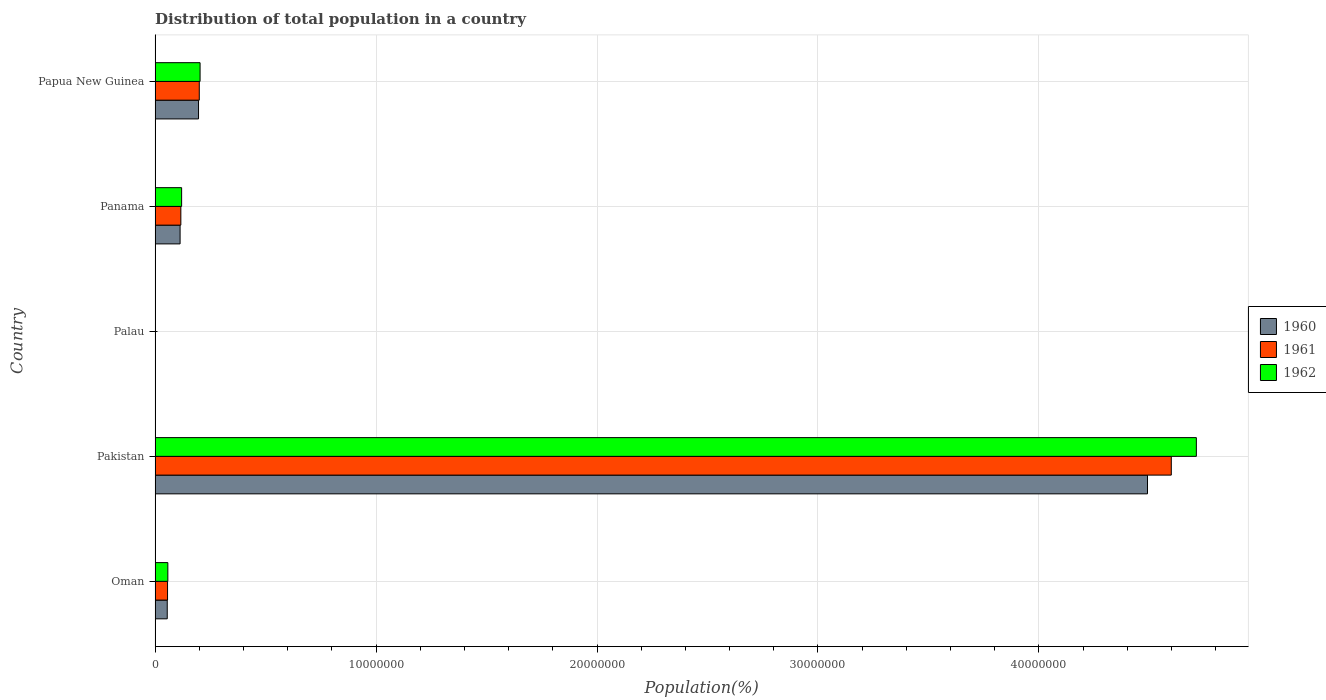How many different coloured bars are there?
Offer a terse response. 3. How many groups of bars are there?
Offer a terse response. 5. Are the number of bars per tick equal to the number of legend labels?
Your answer should be very brief. Yes. Are the number of bars on each tick of the Y-axis equal?
Provide a short and direct response. Yes. How many bars are there on the 4th tick from the top?
Make the answer very short. 3. What is the label of the 1st group of bars from the top?
Offer a terse response. Papua New Guinea. What is the population of in 1961 in Palau?
Make the answer very short. 9901. Across all countries, what is the maximum population of in 1962?
Your answer should be very brief. 4.71e+07. Across all countries, what is the minimum population of in 1962?
Provide a short and direct response. 1.02e+04. In which country was the population of in 1960 maximum?
Offer a very short reply. Pakistan. In which country was the population of in 1960 minimum?
Your response must be concise. Palau. What is the total population of in 1960 in the graph?
Provide a succinct answer. 4.86e+07. What is the difference between the population of in 1961 in Palau and that in Papua New Guinea?
Make the answer very short. -1.99e+06. What is the difference between the population of in 1960 in Papua New Guinea and the population of in 1962 in Palau?
Your answer should be very brief. 1.96e+06. What is the average population of in 1960 per country?
Make the answer very short. 9.71e+06. What is the difference between the population of in 1961 and population of in 1960 in Pakistan?
Your response must be concise. 1.08e+06. What is the ratio of the population of in 1962 in Pakistan to that in Palau?
Provide a succinct answer. 4642.65. What is the difference between the highest and the second highest population of in 1960?
Ensure brevity in your answer.  4.29e+07. What is the difference between the highest and the lowest population of in 1961?
Keep it short and to the point. 4.60e+07. Is the sum of the population of in 1960 in Pakistan and Panama greater than the maximum population of in 1962 across all countries?
Give a very brief answer. No. What does the 2nd bar from the bottom in Pakistan represents?
Make the answer very short. 1961. How many bars are there?
Keep it short and to the point. 15. How many countries are there in the graph?
Keep it short and to the point. 5. What is the difference between two consecutive major ticks on the X-axis?
Your answer should be compact. 1.00e+07. How many legend labels are there?
Give a very brief answer. 3. How are the legend labels stacked?
Keep it short and to the point. Vertical. What is the title of the graph?
Keep it short and to the point. Distribution of total population in a country. What is the label or title of the X-axis?
Provide a short and direct response. Population(%). What is the label or title of the Y-axis?
Your answer should be compact. Country. What is the Population(%) in 1960 in Oman?
Your response must be concise. 5.52e+05. What is the Population(%) in 1961 in Oman?
Ensure brevity in your answer.  5.65e+05. What is the Population(%) in 1962 in Oman?
Offer a very short reply. 5.79e+05. What is the Population(%) in 1960 in Pakistan?
Keep it short and to the point. 4.49e+07. What is the Population(%) of 1961 in Pakistan?
Make the answer very short. 4.60e+07. What is the Population(%) of 1962 in Pakistan?
Offer a terse response. 4.71e+07. What is the Population(%) in 1960 in Palau?
Ensure brevity in your answer.  9638. What is the Population(%) of 1961 in Palau?
Keep it short and to the point. 9901. What is the Population(%) of 1962 in Palau?
Make the answer very short. 1.02e+04. What is the Population(%) of 1960 in Panama?
Offer a terse response. 1.13e+06. What is the Population(%) in 1961 in Panama?
Ensure brevity in your answer.  1.17e+06. What is the Population(%) of 1962 in Panama?
Offer a very short reply. 1.20e+06. What is the Population(%) in 1960 in Papua New Guinea?
Provide a short and direct response. 1.97e+06. What is the Population(%) of 1961 in Papua New Guinea?
Make the answer very short. 2.00e+06. What is the Population(%) of 1962 in Papua New Guinea?
Your response must be concise. 2.04e+06. Across all countries, what is the maximum Population(%) in 1960?
Your response must be concise. 4.49e+07. Across all countries, what is the maximum Population(%) of 1961?
Offer a terse response. 4.60e+07. Across all countries, what is the maximum Population(%) of 1962?
Offer a terse response. 4.71e+07. Across all countries, what is the minimum Population(%) of 1960?
Offer a very short reply. 9638. Across all countries, what is the minimum Population(%) of 1961?
Keep it short and to the point. 9901. Across all countries, what is the minimum Population(%) in 1962?
Provide a succinct answer. 1.02e+04. What is the total Population(%) of 1960 in the graph?
Offer a terse response. 4.86e+07. What is the total Population(%) of 1961 in the graph?
Offer a very short reply. 4.97e+07. What is the total Population(%) in 1962 in the graph?
Your response must be concise. 5.10e+07. What is the difference between the Population(%) of 1960 in Oman and that in Pakistan?
Your answer should be compact. -4.44e+07. What is the difference between the Population(%) of 1961 in Oman and that in Pakistan?
Provide a succinct answer. -4.54e+07. What is the difference between the Population(%) in 1962 in Oman and that in Pakistan?
Offer a terse response. -4.65e+07. What is the difference between the Population(%) in 1960 in Oman and that in Palau?
Ensure brevity in your answer.  5.42e+05. What is the difference between the Population(%) of 1961 in Oman and that in Palau?
Provide a short and direct response. 5.55e+05. What is the difference between the Population(%) of 1962 in Oman and that in Palau?
Your answer should be compact. 5.69e+05. What is the difference between the Population(%) in 1960 in Oman and that in Panama?
Your response must be concise. -5.81e+05. What is the difference between the Population(%) of 1961 in Oman and that in Panama?
Ensure brevity in your answer.  -6.02e+05. What is the difference between the Population(%) of 1962 in Oman and that in Panama?
Provide a short and direct response. -6.24e+05. What is the difference between the Population(%) in 1960 in Oman and that in Papua New Guinea?
Provide a succinct answer. -1.42e+06. What is the difference between the Population(%) of 1961 in Oman and that in Papua New Guinea?
Keep it short and to the point. -1.44e+06. What is the difference between the Population(%) of 1962 in Oman and that in Papua New Guinea?
Your response must be concise. -1.46e+06. What is the difference between the Population(%) in 1960 in Pakistan and that in Palau?
Provide a short and direct response. 4.49e+07. What is the difference between the Population(%) of 1961 in Pakistan and that in Palau?
Provide a succinct answer. 4.60e+07. What is the difference between the Population(%) in 1962 in Pakistan and that in Palau?
Offer a terse response. 4.71e+07. What is the difference between the Population(%) of 1960 in Pakistan and that in Panama?
Offer a terse response. 4.38e+07. What is the difference between the Population(%) of 1961 in Pakistan and that in Panama?
Give a very brief answer. 4.48e+07. What is the difference between the Population(%) in 1962 in Pakistan and that in Panama?
Your answer should be compact. 4.59e+07. What is the difference between the Population(%) of 1960 in Pakistan and that in Papua New Guinea?
Your answer should be very brief. 4.29e+07. What is the difference between the Population(%) of 1961 in Pakistan and that in Papua New Guinea?
Offer a very short reply. 4.40e+07. What is the difference between the Population(%) of 1962 in Pakistan and that in Papua New Guinea?
Make the answer very short. 4.51e+07. What is the difference between the Population(%) in 1960 in Palau and that in Panama?
Your response must be concise. -1.12e+06. What is the difference between the Population(%) in 1961 in Palau and that in Panama?
Ensure brevity in your answer.  -1.16e+06. What is the difference between the Population(%) of 1962 in Palau and that in Panama?
Offer a terse response. -1.19e+06. What is the difference between the Population(%) in 1960 in Palau and that in Papua New Guinea?
Keep it short and to the point. -1.96e+06. What is the difference between the Population(%) in 1961 in Palau and that in Papua New Guinea?
Offer a very short reply. -1.99e+06. What is the difference between the Population(%) in 1962 in Palau and that in Papua New Guinea?
Your response must be concise. -2.03e+06. What is the difference between the Population(%) of 1960 in Panama and that in Papua New Guinea?
Your response must be concise. -8.34e+05. What is the difference between the Population(%) of 1961 in Panama and that in Papua New Guinea?
Your response must be concise. -8.34e+05. What is the difference between the Population(%) of 1962 in Panama and that in Papua New Guinea?
Offer a very short reply. -8.35e+05. What is the difference between the Population(%) of 1960 in Oman and the Population(%) of 1961 in Pakistan?
Offer a terse response. -4.54e+07. What is the difference between the Population(%) of 1960 in Oman and the Population(%) of 1962 in Pakistan?
Your response must be concise. -4.66e+07. What is the difference between the Population(%) in 1961 in Oman and the Population(%) in 1962 in Pakistan?
Your response must be concise. -4.66e+07. What is the difference between the Population(%) of 1960 in Oman and the Population(%) of 1961 in Palau?
Your response must be concise. 5.42e+05. What is the difference between the Population(%) in 1960 in Oman and the Population(%) in 1962 in Palau?
Your answer should be very brief. 5.42e+05. What is the difference between the Population(%) of 1961 in Oman and the Population(%) of 1962 in Palau?
Make the answer very short. 5.55e+05. What is the difference between the Population(%) in 1960 in Oman and the Population(%) in 1961 in Panama?
Your answer should be very brief. -6.15e+05. What is the difference between the Population(%) of 1960 in Oman and the Population(%) of 1962 in Panama?
Ensure brevity in your answer.  -6.51e+05. What is the difference between the Population(%) of 1961 in Oman and the Population(%) of 1962 in Panama?
Your response must be concise. -6.37e+05. What is the difference between the Population(%) in 1960 in Oman and the Population(%) in 1961 in Papua New Guinea?
Your answer should be compact. -1.45e+06. What is the difference between the Population(%) of 1960 in Oman and the Population(%) of 1962 in Papua New Guinea?
Offer a very short reply. -1.49e+06. What is the difference between the Population(%) in 1961 in Oman and the Population(%) in 1962 in Papua New Guinea?
Ensure brevity in your answer.  -1.47e+06. What is the difference between the Population(%) in 1960 in Pakistan and the Population(%) in 1961 in Palau?
Offer a terse response. 4.49e+07. What is the difference between the Population(%) of 1960 in Pakistan and the Population(%) of 1962 in Palau?
Your answer should be compact. 4.49e+07. What is the difference between the Population(%) of 1961 in Pakistan and the Population(%) of 1962 in Palau?
Offer a terse response. 4.60e+07. What is the difference between the Population(%) in 1960 in Pakistan and the Population(%) in 1961 in Panama?
Provide a succinct answer. 4.37e+07. What is the difference between the Population(%) in 1960 in Pakistan and the Population(%) in 1962 in Panama?
Provide a succinct answer. 4.37e+07. What is the difference between the Population(%) in 1961 in Pakistan and the Population(%) in 1962 in Panama?
Keep it short and to the point. 4.48e+07. What is the difference between the Population(%) in 1960 in Pakistan and the Population(%) in 1961 in Papua New Guinea?
Your response must be concise. 4.29e+07. What is the difference between the Population(%) of 1960 in Pakistan and the Population(%) of 1962 in Papua New Guinea?
Make the answer very short. 4.29e+07. What is the difference between the Population(%) in 1961 in Pakistan and the Population(%) in 1962 in Papua New Guinea?
Your response must be concise. 4.40e+07. What is the difference between the Population(%) in 1960 in Palau and the Population(%) in 1961 in Panama?
Ensure brevity in your answer.  -1.16e+06. What is the difference between the Population(%) of 1960 in Palau and the Population(%) of 1962 in Panama?
Offer a very short reply. -1.19e+06. What is the difference between the Population(%) in 1961 in Palau and the Population(%) in 1962 in Panama?
Provide a short and direct response. -1.19e+06. What is the difference between the Population(%) of 1960 in Palau and the Population(%) of 1961 in Papua New Guinea?
Keep it short and to the point. -1.99e+06. What is the difference between the Population(%) in 1960 in Palau and the Population(%) in 1962 in Papua New Guinea?
Offer a terse response. -2.03e+06. What is the difference between the Population(%) in 1961 in Palau and the Population(%) in 1962 in Papua New Guinea?
Keep it short and to the point. -2.03e+06. What is the difference between the Population(%) of 1960 in Panama and the Population(%) of 1961 in Papua New Guinea?
Make the answer very short. -8.68e+05. What is the difference between the Population(%) of 1960 in Panama and the Population(%) of 1962 in Papua New Guinea?
Provide a short and direct response. -9.04e+05. What is the difference between the Population(%) in 1961 in Panama and the Population(%) in 1962 in Papua New Guinea?
Ensure brevity in your answer.  -8.70e+05. What is the average Population(%) of 1960 per country?
Ensure brevity in your answer.  9.71e+06. What is the average Population(%) in 1961 per country?
Ensure brevity in your answer.  9.95e+06. What is the average Population(%) of 1962 per country?
Keep it short and to the point. 1.02e+07. What is the difference between the Population(%) in 1960 and Population(%) in 1961 in Oman?
Keep it short and to the point. -1.32e+04. What is the difference between the Population(%) of 1960 and Population(%) of 1962 in Oman?
Ensure brevity in your answer.  -2.71e+04. What is the difference between the Population(%) of 1961 and Population(%) of 1962 in Oman?
Your response must be concise. -1.39e+04. What is the difference between the Population(%) of 1960 and Population(%) of 1961 in Pakistan?
Offer a terse response. -1.08e+06. What is the difference between the Population(%) of 1960 and Population(%) of 1962 in Pakistan?
Offer a terse response. -2.21e+06. What is the difference between the Population(%) of 1961 and Population(%) of 1962 in Pakistan?
Make the answer very short. -1.13e+06. What is the difference between the Population(%) of 1960 and Population(%) of 1961 in Palau?
Your answer should be very brief. -263. What is the difference between the Population(%) in 1960 and Population(%) in 1962 in Palau?
Give a very brief answer. -512. What is the difference between the Population(%) of 1961 and Population(%) of 1962 in Palau?
Offer a very short reply. -249. What is the difference between the Population(%) in 1960 and Population(%) in 1961 in Panama?
Provide a succinct answer. -3.41e+04. What is the difference between the Population(%) in 1960 and Population(%) in 1962 in Panama?
Provide a short and direct response. -6.94e+04. What is the difference between the Population(%) in 1961 and Population(%) in 1962 in Panama?
Give a very brief answer. -3.53e+04. What is the difference between the Population(%) in 1960 and Population(%) in 1961 in Papua New Guinea?
Keep it short and to the point. -3.41e+04. What is the difference between the Population(%) of 1960 and Population(%) of 1962 in Papua New Guinea?
Give a very brief answer. -7.02e+04. What is the difference between the Population(%) in 1961 and Population(%) in 1962 in Papua New Guinea?
Ensure brevity in your answer.  -3.61e+04. What is the ratio of the Population(%) in 1960 in Oman to that in Pakistan?
Your answer should be very brief. 0.01. What is the ratio of the Population(%) of 1961 in Oman to that in Pakistan?
Ensure brevity in your answer.  0.01. What is the ratio of the Population(%) of 1962 in Oman to that in Pakistan?
Your answer should be compact. 0.01. What is the ratio of the Population(%) of 1960 in Oman to that in Palau?
Keep it short and to the point. 57.25. What is the ratio of the Population(%) of 1961 in Oman to that in Palau?
Ensure brevity in your answer.  57.05. What is the ratio of the Population(%) in 1962 in Oman to that in Palau?
Your answer should be compact. 57.03. What is the ratio of the Population(%) of 1960 in Oman to that in Panama?
Make the answer very short. 0.49. What is the ratio of the Population(%) in 1961 in Oman to that in Panama?
Give a very brief answer. 0.48. What is the ratio of the Population(%) in 1962 in Oman to that in Panama?
Your answer should be compact. 0.48. What is the ratio of the Population(%) of 1960 in Oman to that in Papua New Guinea?
Provide a short and direct response. 0.28. What is the ratio of the Population(%) of 1961 in Oman to that in Papua New Guinea?
Provide a succinct answer. 0.28. What is the ratio of the Population(%) in 1962 in Oman to that in Papua New Guinea?
Your answer should be very brief. 0.28. What is the ratio of the Population(%) in 1960 in Pakistan to that in Palau?
Your response must be concise. 4659.87. What is the ratio of the Population(%) of 1961 in Pakistan to that in Palau?
Offer a terse response. 4644.83. What is the ratio of the Population(%) in 1962 in Pakistan to that in Palau?
Provide a succinct answer. 4642.65. What is the ratio of the Population(%) of 1960 in Pakistan to that in Panama?
Offer a terse response. 39.64. What is the ratio of the Population(%) of 1961 in Pakistan to that in Panama?
Give a very brief answer. 39.41. What is the ratio of the Population(%) of 1962 in Pakistan to that in Panama?
Your response must be concise. 39.19. What is the ratio of the Population(%) in 1960 in Pakistan to that in Papua New Guinea?
Provide a short and direct response. 22.83. What is the ratio of the Population(%) of 1961 in Pakistan to that in Papua New Guinea?
Provide a short and direct response. 22.98. What is the ratio of the Population(%) in 1962 in Pakistan to that in Papua New Guinea?
Give a very brief answer. 23.13. What is the ratio of the Population(%) in 1960 in Palau to that in Panama?
Your answer should be very brief. 0.01. What is the ratio of the Population(%) in 1961 in Palau to that in Panama?
Provide a short and direct response. 0.01. What is the ratio of the Population(%) of 1962 in Palau to that in Panama?
Your answer should be compact. 0.01. What is the ratio of the Population(%) of 1960 in Palau to that in Papua New Guinea?
Your answer should be very brief. 0. What is the ratio of the Population(%) of 1961 in Palau to that in Papua New Guinea?
Provide a succinct answer. 0. What is the ratio of the Population(%) of 1962 in Palau to that in Papua New Guinea?
Your answer should be very brief. 0.01. What is the ratio of the Population(%) in 1960 in Panama to that in Papua New Guinea?
Offer a very short reply. 0.58. What is the ratio of the Population(%) in 1961 in Panama to that in Papua New Guinea?
Keep it short and to the point. 0.58. What is the ratio of the Population(%) of 1962 in Panama to that in Papua New Guinea?
Keep it short and to the point. 0.59. What is the difference between the highest and the second highest Population(%) in 1960?
Offer a terse response. 4.29e+07. What is the difference between the highest and the second highest Population(%) in 1961?
Offer a terse response. 4.40e+07. What is the difference between the highest and the second highest Population(%) of 1962?
Keep it short and to the point. 4.51e+07. What is the difference between the highest and the lowest Population(%) in 1960?
Give a very brief answer. 4.49e+07. What is the difference between the highest and the lowest Population(%) in 1961?
Keep it short and to the point. 4.60e+07. What is the difference between the highest and the lowest Population(%) in 1962?
Offer a terse response. 4.71e+07. 